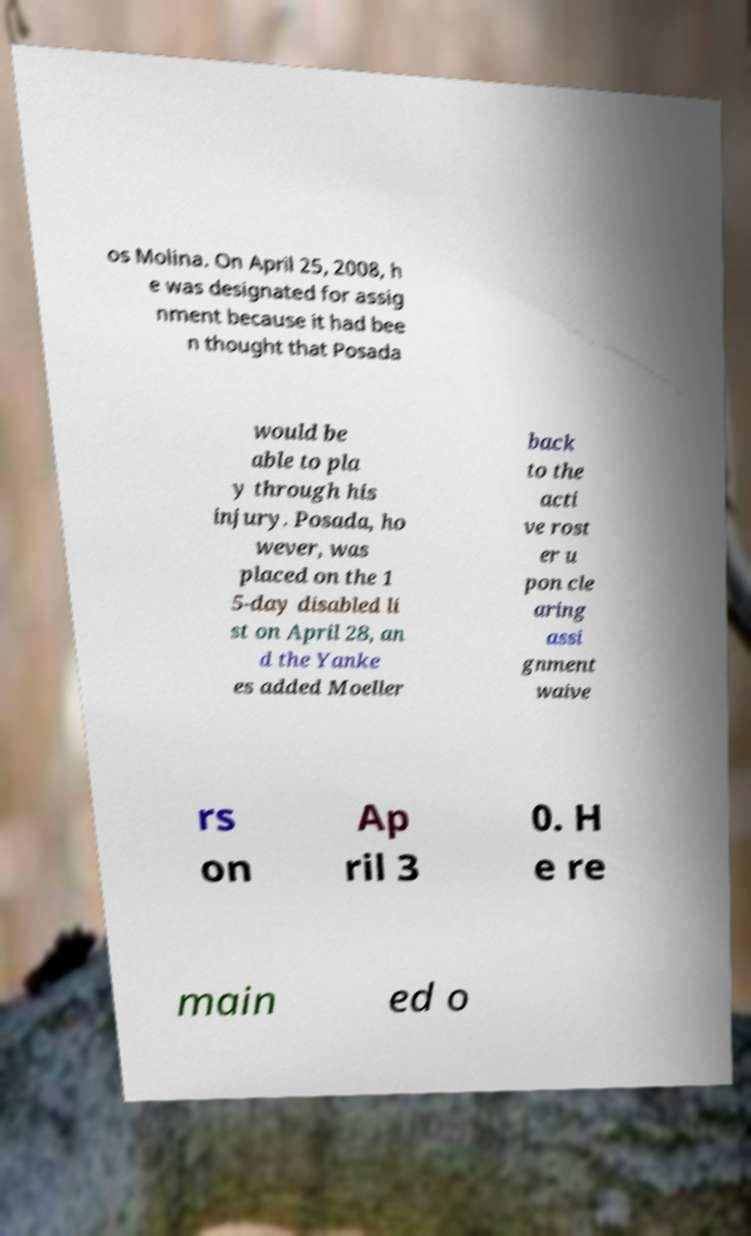Please identify and transcribe the text found in this image. os Molina. On April 25, 2008, h e was designated for assig nment because it had bee n thought that Posada would be able to pla y through his injury. Posada, ho wever, was placed on the 1 5-day disabled li st on April 28, an d the Yanke es added Moeller back to the acti ve rost er u pon cle aring assi gnment waive rs on Ap ril 3 0. H e re main ed o 